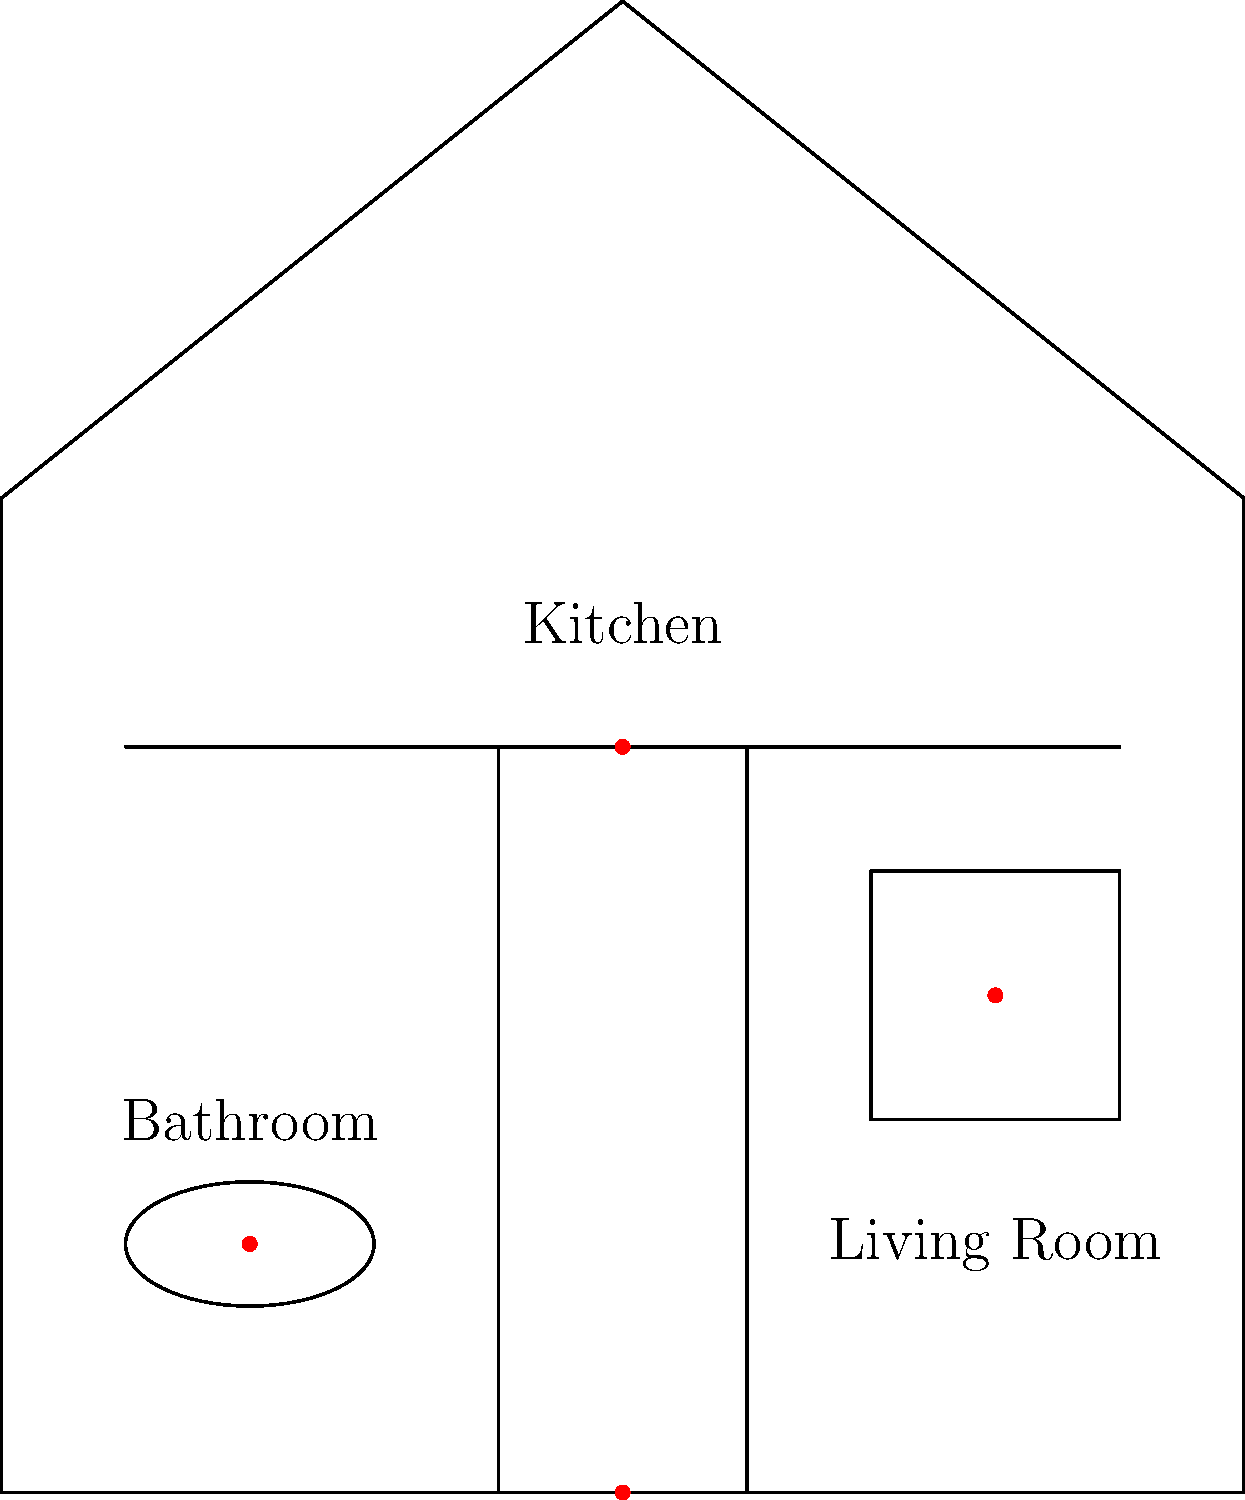Match the following everyday objects to their germ hotspots in the house diagram: 
1. Doorknob
2. Kitchen sponge
3. Toilet seat
4. Remote control Let's go through each germ hotspot in the house diagram and match it to the correct everyday object:

1. Kitchen counter (red dot at (50,60)):
   This area is likely to have the most germs from food preparation and cleaning. The kitchen sponge is often the germiest item in the house because it's damp and collects food particles.

2. Toilet (red dot at (20,20)):
   The bathroom, especially the toilet, is a known germ hotspot. The toilet seat is frequently touched and can harbor many bacteria.

3. Door (red dot at (50,0)):
   The doorknob is touched by everyone entering and leaving the house, making it a prime location for germ transfer.

4. Living Room (red dot at (80,40)):
   In the living room, commonly touched items like the remote control can accumulate germs from multiple users.

Therefore, the matching is:
1. Doorknob - Door (50,0)
2. Kitchen sponge - Kitchen counter (50,60)
3. Toilet seat - Toilet (20,20)
4. Remote control - Living Room (80,40)
Answer: 1-Door, 2-Kitchen counter, 3-Toilet, 4-Living Room 